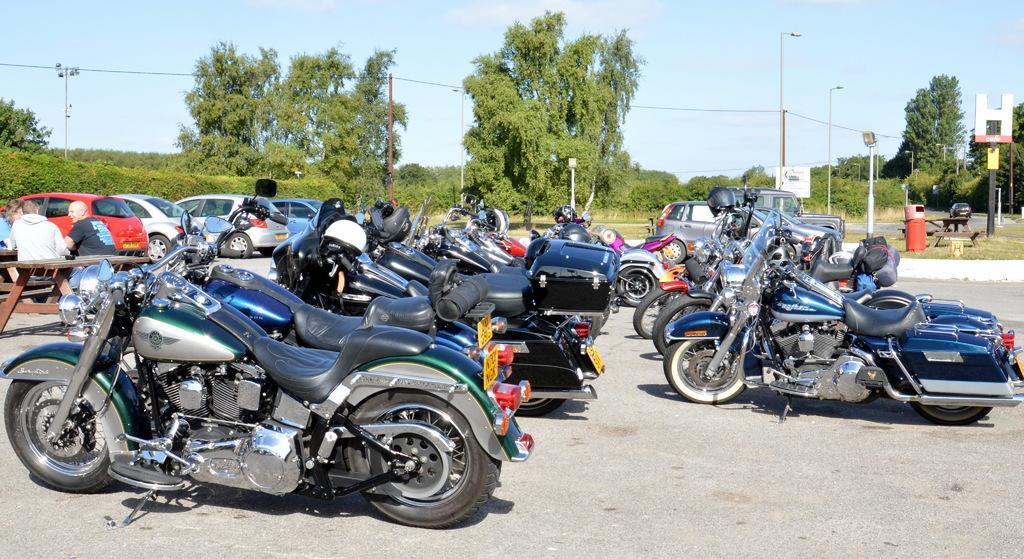Describe this image in one or two sentences. In this image I can see few vehicles on the road and I can see few persons sitting, background I can see trees in green color, few light poles and the sky is in white color. 